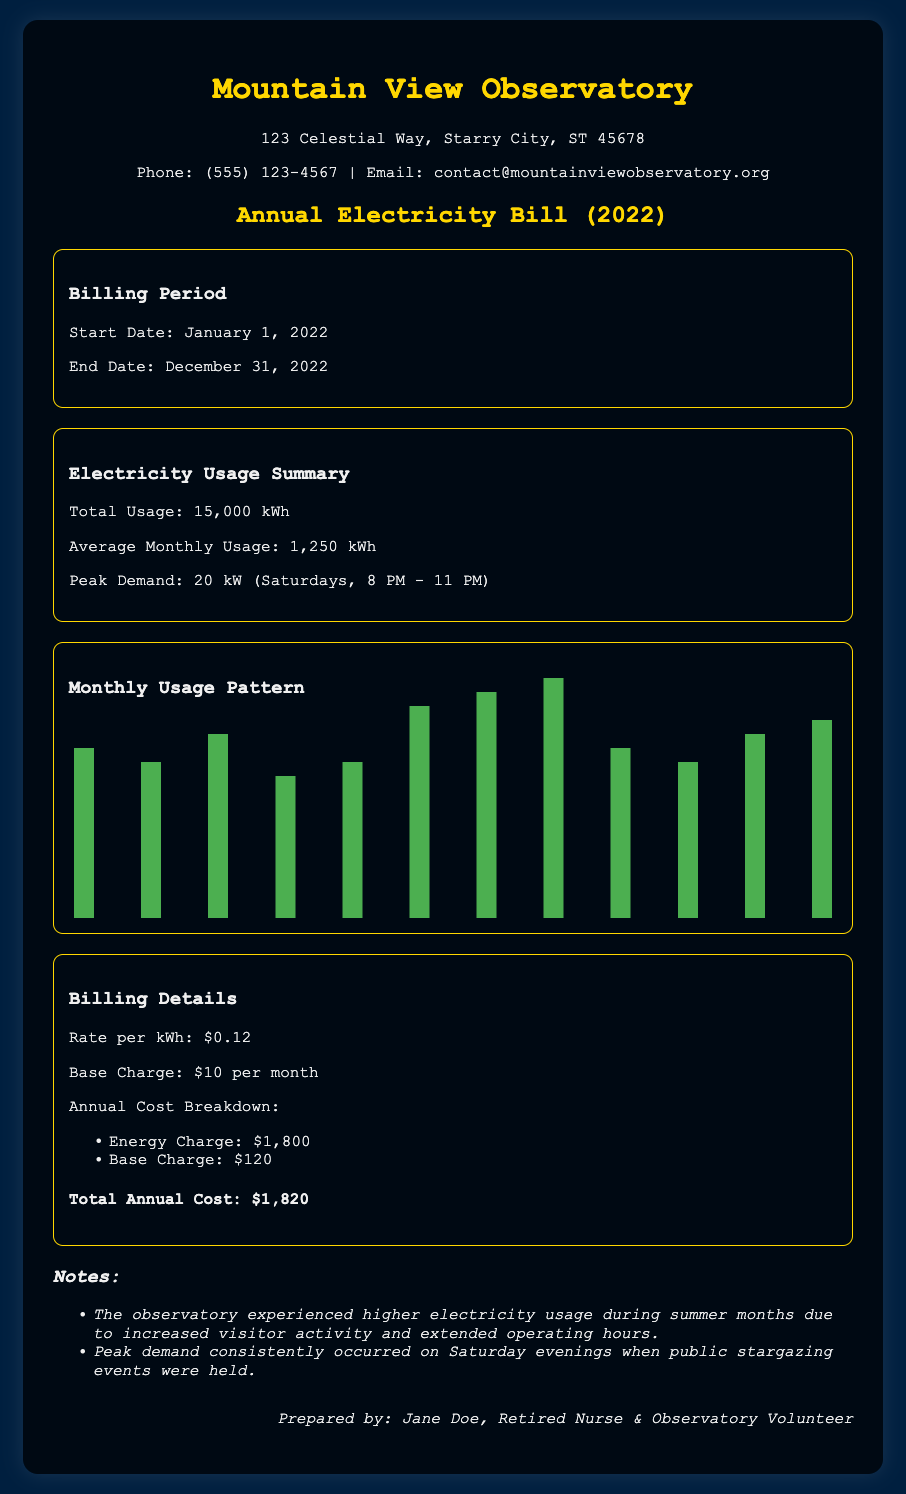What was the total electricity usage for the observatory? The total electricity usage is stated in the document under the usage summary section, which is 15,000 kWh.
Answer: 15,000 kWh What is the average monthly usage? The average monthly usage can be found in the electricity usage summary, indicated as 1,250 kWh.
Answer: 1,250 kWh What was the peak demand time? The peak demand time is mentioned in the usage summary where it specifies the time as Saturdays, 8 PM - 11 PM.
Answer: Saturdays, 8 PM - 11 PM How much did the observatory spend on energy charges? The annual cost breakdown indicates that the energy charge amounted to $1,800.
Answer: $1,800 When does the observatory experience higher electricity usage? The notes section mentions that higher electricity usage occurs during summer months due to increased visitor activity.
Answer: Summer months What is the total annual cost of the electricity bill? The total annual cost is stated at the end of the billing details as $1,820.
Answer: $1,820 What was the base charge per month? The document specifies that the base charge is $10 per month.
Answer: $10 How many kWh were used in July? The monthly usage pattern presents the usage for July as 1,600 kWh.
Answer: 1,600 kWh What percentage of the total annual cost are the energy charges? The energy charge is $1,800 and the total annual cost is $1,820, which means it forms the majority of the cost.
Answer: 98.9% 